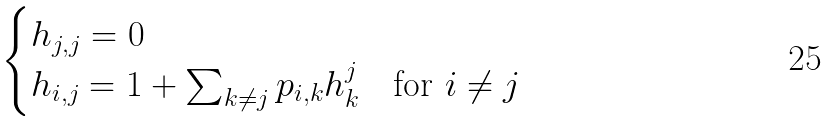Convert formula to latex. <formula><loc_0><loc_0><loc_500><loc_500>\begin{cases} h _ { j , j } = 0 & \\ h _ { i , j } = 1 + \sum _ { k \neq j } { p _ { i , k } h _ { k } ^ { j } } & \text {for } i \neq j \end{cases}</formula> 